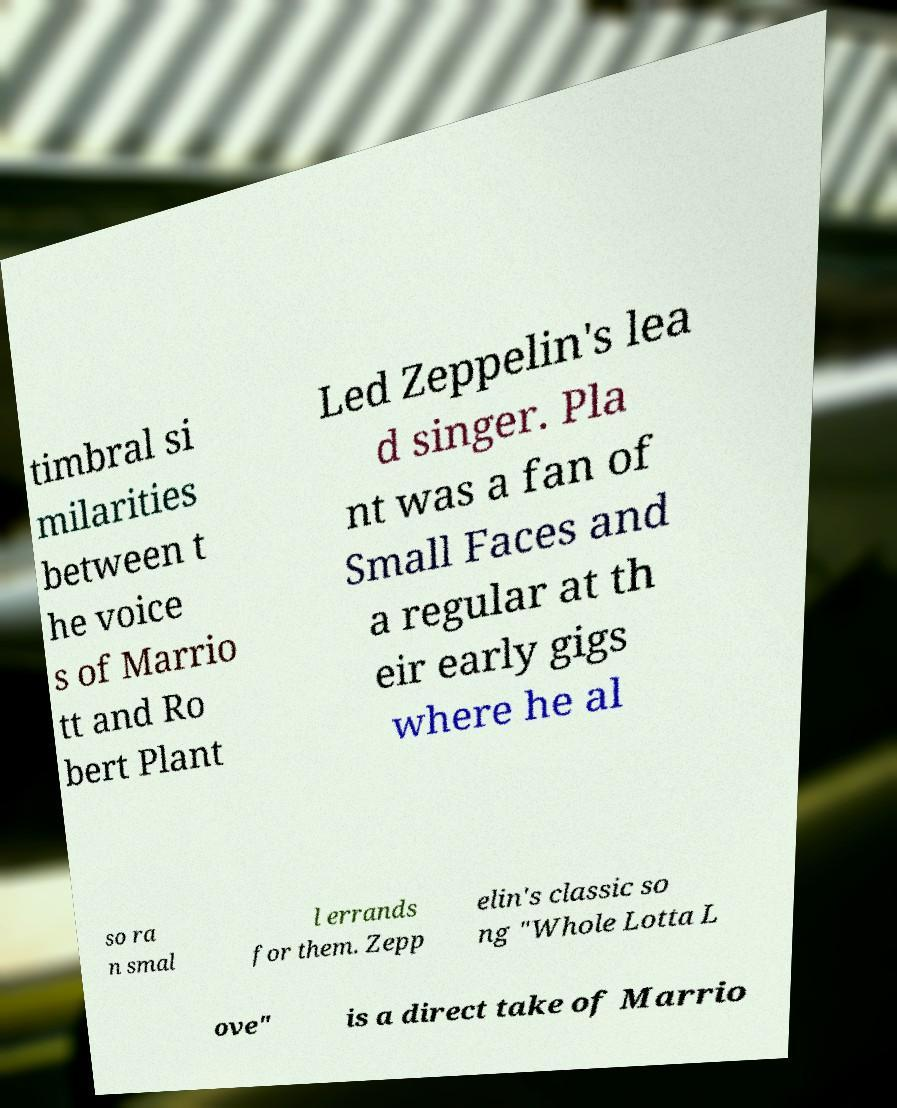There's text embedded in this image that I need extracted. Can you transcribe it verbatim? timbral si milarities between t he voice s of Marrio tt and Ro bert Plant Led Zeppelin's lea d singer. Pla nt was a fan of Small Faces and a regular at th eir early gigs where he al so ra n smal l errands for them. Zepp elin's classic so ng "Whole Lotta L ove" is a direct take of Marrio 